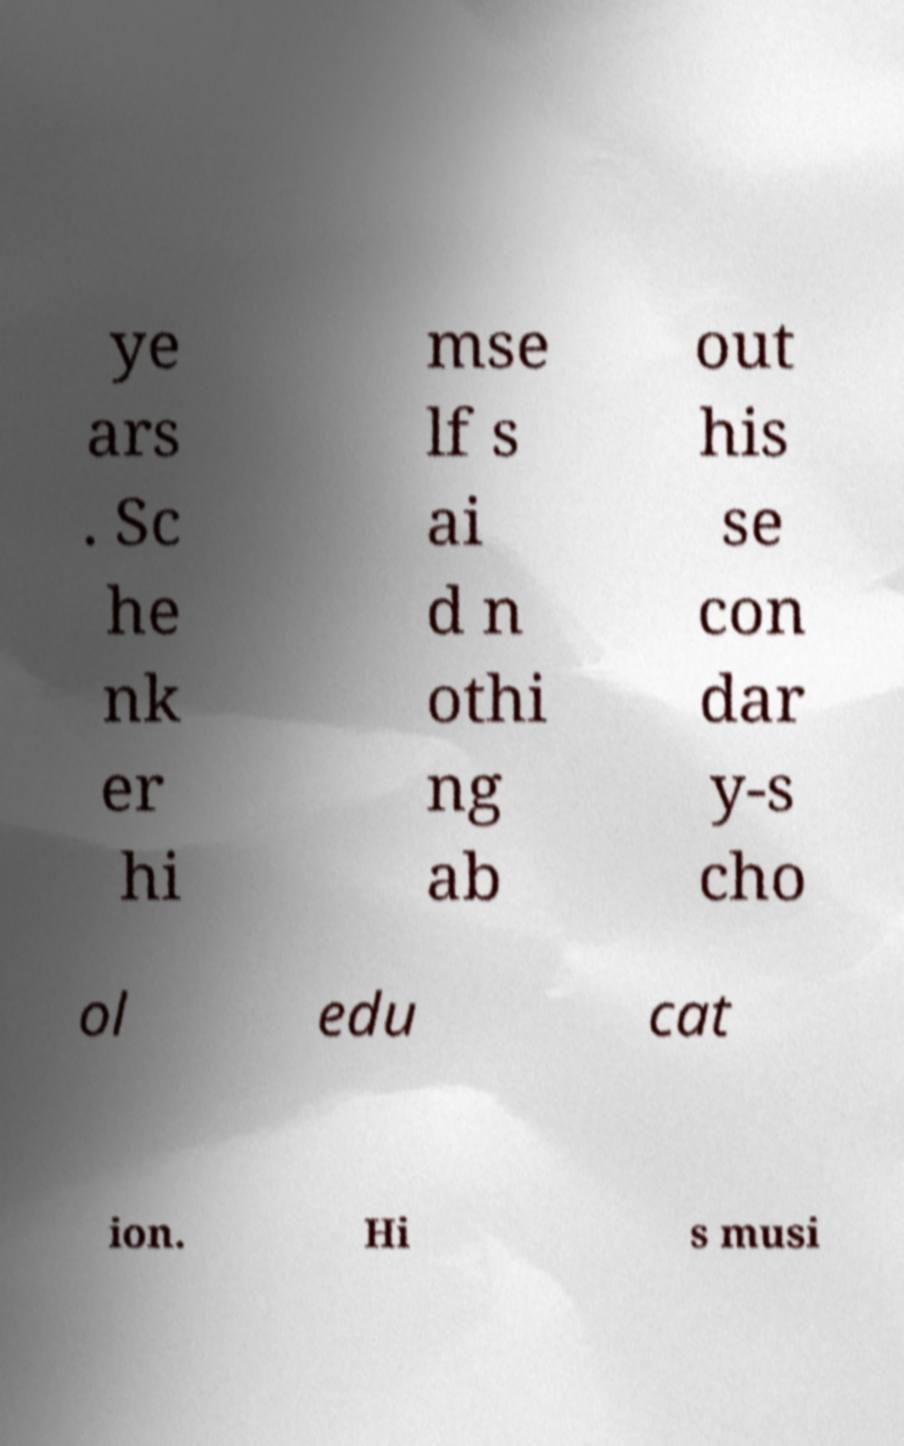Can you accurately transcribe the text from the provided image for me? ye ars . Sc he nk er hi mse lf s ai d n othi ng ab out his se con dar y-s cho ol edu cat ion. Hi s musi 